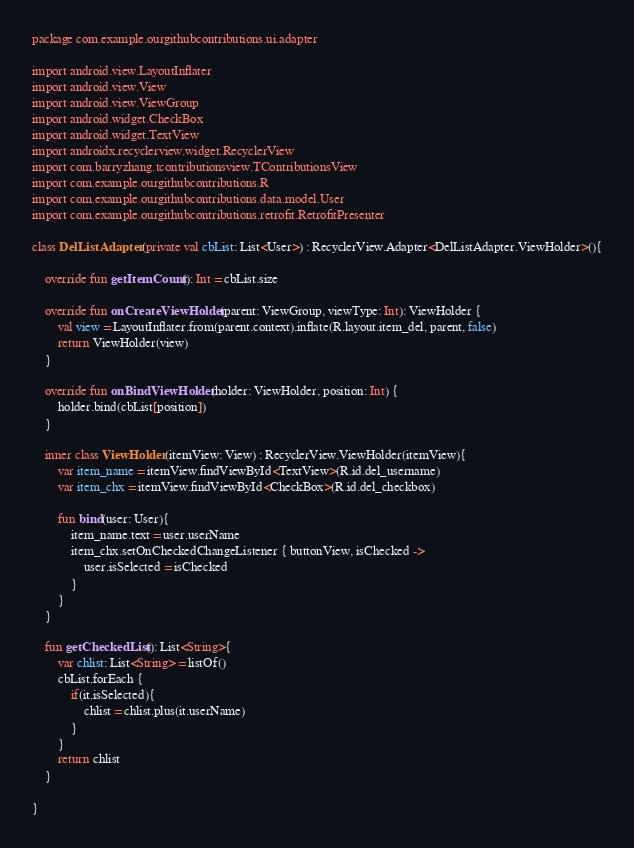<code> <loc_0><loc_0><loc_500><loc_500><_Kotlin_>package com.example.ourgithubcontributions.ui.adapter

import android.view.LayoutInflater
import android.view.View
import android.view.ViewGroup
import android.widget.CheckBox
import android.widget.TextView
import androidx.recyclerview.widget.RecyclerView
import com.barryzhang.tcontributionsview.TContributionsView
import com.example.ourgithubcontributions.R
import com.example.ourgithubcontributions.data.model.User
import com.example.ourgithubcontributions.retrofit.RetrofitPresenter

class DelListAdapter (private val cbList: List<User>) : RecyclerView.Adapter<DelListAdapter.ViewHolder>(){

    override fun getItemCount(): Int = cbList.size

    override fun onCreateViewHolder(parent: ViewGroup, viewType: Int): ViewHolder {
        val view = LayoutInflater.from(parent.context).inflate(R.layout.item_del, parent, false)
        return ViewHolder(view)
    }

    override fun onBindViewHolder(holder: ViewHolder, position: Int) {
        holder.bind(cbList[position])
    }

    inner class ViewHolder(itemView: View) : RecyclerView.ViewHolder(itemView){
        var item_name = itemView.findViewById<TextView>(R.id.del_username)
        var item_chx = itemView.findViewById<CheckBox>(R.id.del_checkbox)

        fun bind(user: User){
            item_name.text = user.userName
            item_chx.setOnCheckedChangeListener { buttonView, isChecked ->
                user.isSelected = isChecked
            }
        }
    }

    fun getCheckedList(): List<String>{
        var chlist: List<String> = listOf()
        cbList.forEach {
            if(it.isSelected){
                chlist = chlist.plus(it.userName)
            }
        }
        return chlist
    }

}</code> 